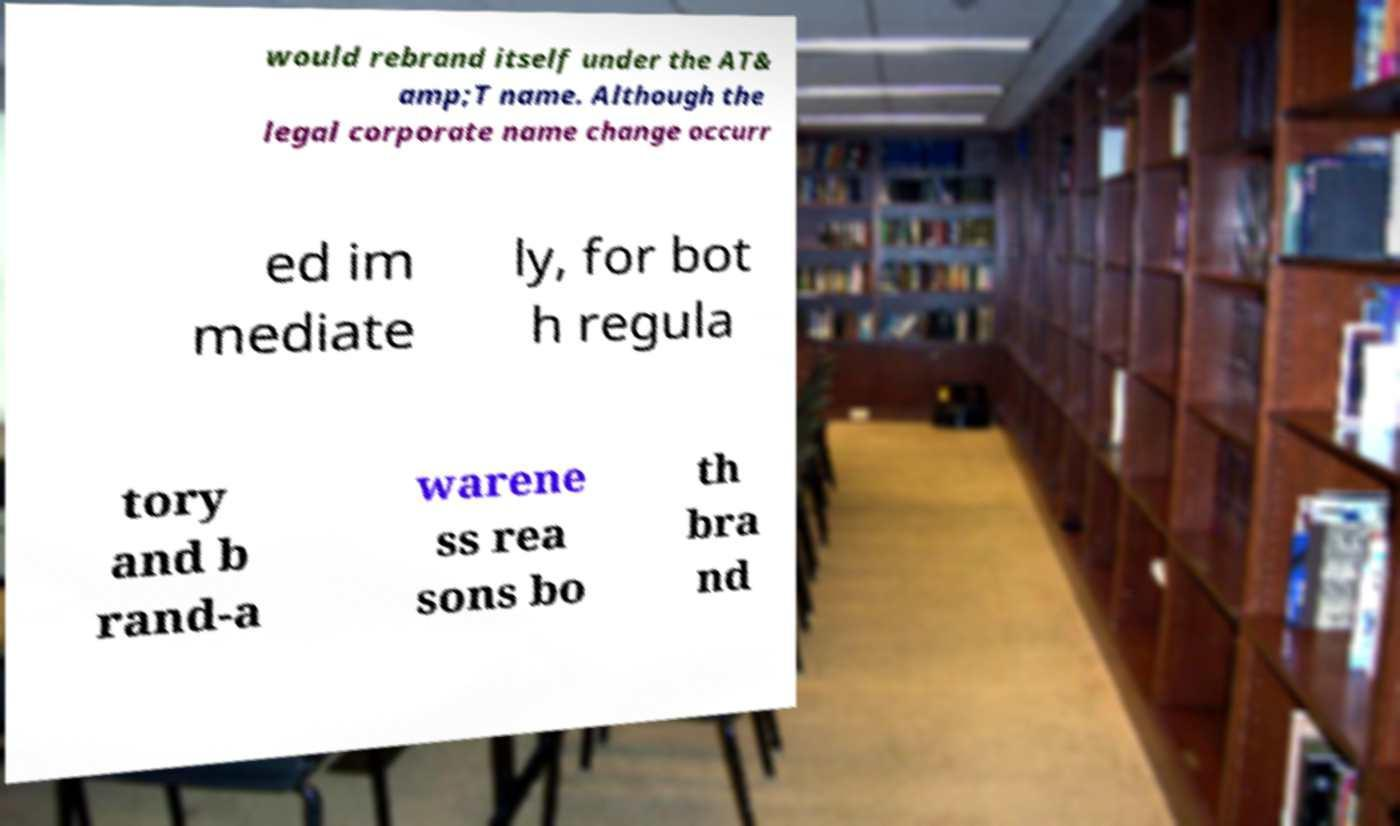For documentation purposes, I need the text within this image transcribed. Could you provide that? would rebrand itself under the AT& amp;T name. Although the legal corporate name change occurr ed im mediate ly, for bot h regula tory and b rand-a warene ss rea sons bo th bra nd 